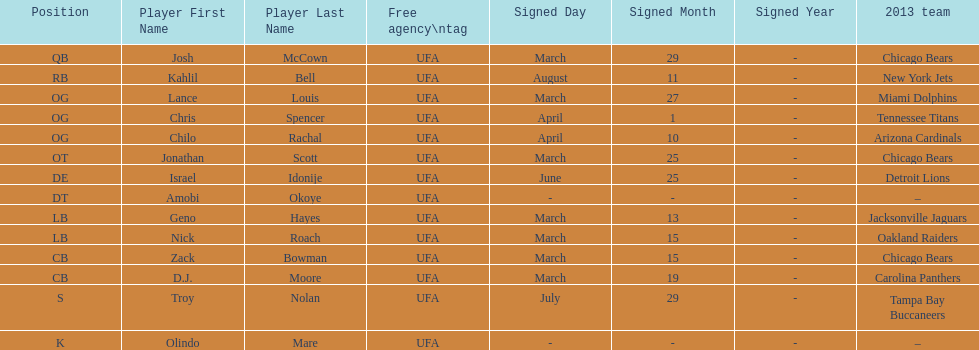Geno hayes and nick roach both played which position? LB. Parse the table in full. {'header': ['Position', 'Player First Name', 'Player Last Name', 'Free agency\\ntag', 'Signed Day', 'Signed Month', 'Signed Year', '2013 team'], 'rows': [['QB', 'Josh', 'McCown', 'UFA', 'March', '29', '-', 'Chicago Bears'], ['RB', 'Kahlil', 'Bell', 'UFA', 'August', '11', '-', 'New York Jets'], ['OG', 'Lance', 'Louis', 'UFA', 'March', '27', '-', 'Miami Dolphins'], ['OG', 'Chris', 'Spencer', 'UFA', 'April', '1', '-', 'Tennessee Titans'], ['OG', 'Chilo', 'Rachal', 'UFA', 'April', '10', '-', 'Arizona Cardinals'], ['OT', 'Jonathan', 'Scott', 'UFA', 'March', '25', '-', 'Chicago Bears'], ['DE', 'Israel', 'Idonije', 'UFA', 'June', '25', '-', 'Detroit Lions'], ['DT', 'Amobi', 'Okoye', 'UFA', '-', '-', '-', '–'], ['LB', 'Geno', 'Hayes', 'UFA', 'March', '13', '-', 'Jacksonville Jaguars'], ['LB', 'Nick', 'Roach', 'UFA', 'March', '15', '-', 'Oakland Raiders'], ['CB', 'Zack', 'Bowman', 'UFA', 'March', '15', '-', 'Chicago Bears'], ['CB', 'D.J.', 'Moore', 'UFA', 'March', '19', '-', 'Carolina Panthers'], ['S', 'Troy', 'Nolan', 'UFA', 'July', '29', '-', 'Tampa Bay Buccaneers'], ['K', 'Olindo', 'Mare', 'UFA', '-', '-', '-', '–']]} 